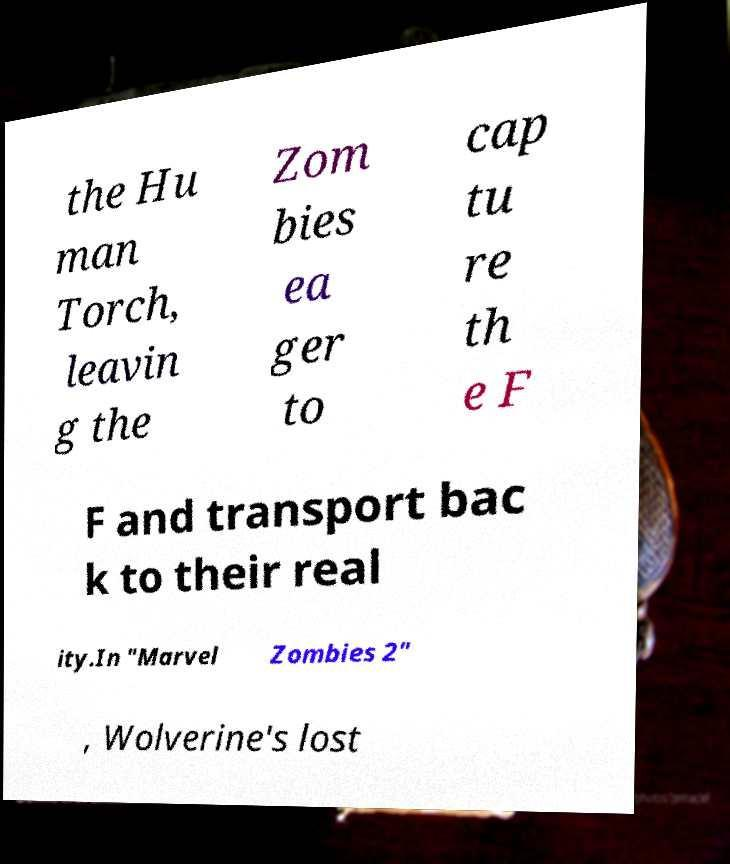Can you accurately transcribe the text from the provided image for me? the Hu man Torch, leavin g the Zom bies ea ger to cap tu re th e F F and transport bac k to their real ity.In "Marvel Zombies 2" , Wolverine's lost 